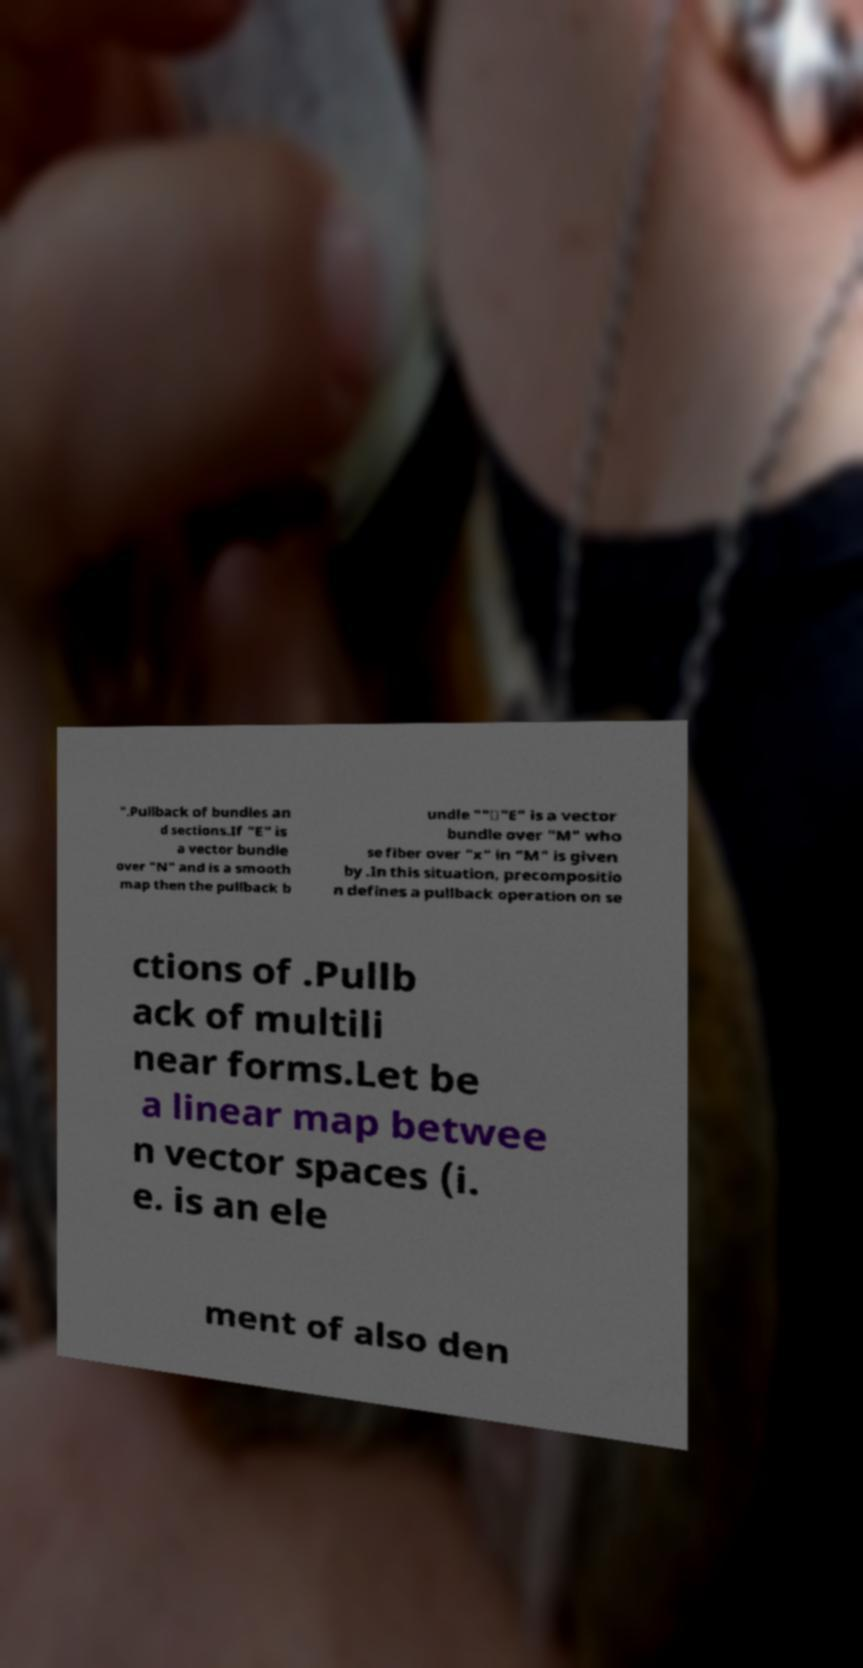Can you read and provide the text displayed in the image?This photo seems to have some interesting text. Can you extract and type it out for me? ".Pullback of bundles an d sections.If "E" is a vector bundle over "N" and is a smooth map then the pullback b undle ""∗"E" is a vector bundle over "M" who se fiber over "x" in "M" is given by .In this situation, precompositio n defines a pullback operation on se ctions of .Pullb ack of multili near forms.Let be a linear map betwee n vector spaces (i. e. is an ele ment of also den 